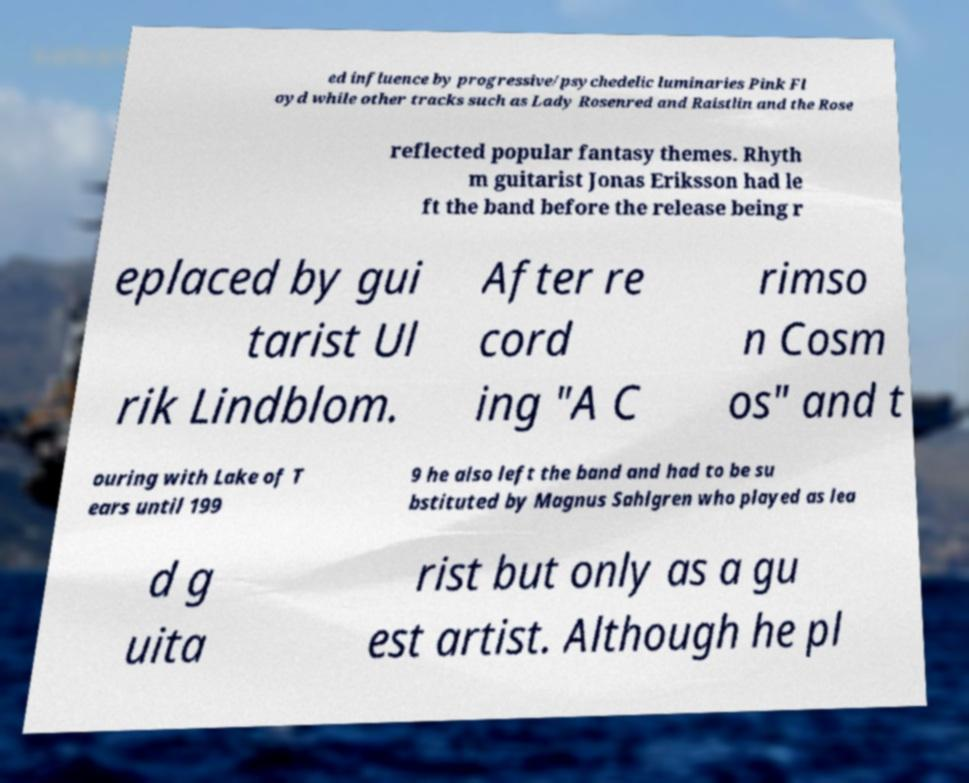Could you extract and type out the text from this image? ed influence by progressive/psychedelic luminaries Pink Fl oyd while other tracks such as Lady Rosenred and Raistlin and the Rose reflected popular fantasy themes. Rhyth m guitarist Jonas Eriksson had le ft the band before the release being r eplaced by gui tarist Ul rik Lindblom. After re cord ing "A C rimso n Cosm os" and t ouring with Lake of T ears until 199 9 he also left the band and had to be su bstituted by Magnus Sahlgren who played as lea d g uita rist but only as a gu est artist. Although he pl 